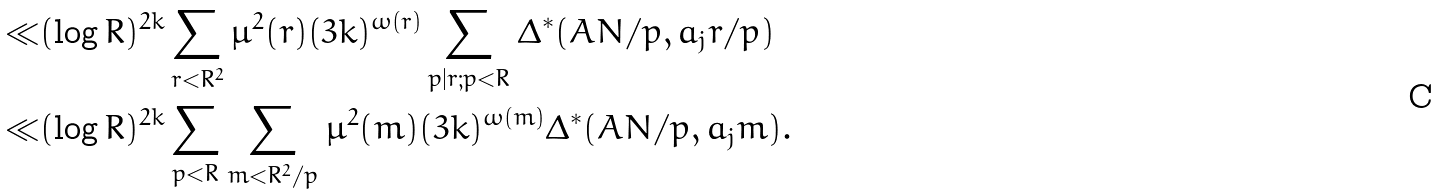Convert formula to latex. <formula><loc_0><loc_0><loc_500><loc_500>\ll & ( \log R ) ^ { 2 k } \sum _ { r < R ^ { 2 } } \mu ^ { 2 } ( r ) ( 3 k ) ^ { \omega ( r ) } \sum _ { p | r ; p < R } \Delta ^ { * } ( A N / p , a _ { j } r / p ) \\ \ll & ( \log R ) ^ { 2 k } \sum _ { p < R } \sum _ { m < R ^ { 2 } / p } \mu ^ { 2 } ( m ) ( 3 k ) ^ { \omega ( m ) } \Delta ^ { * } ( A N / p , a _ { j } m ) .</formula> 